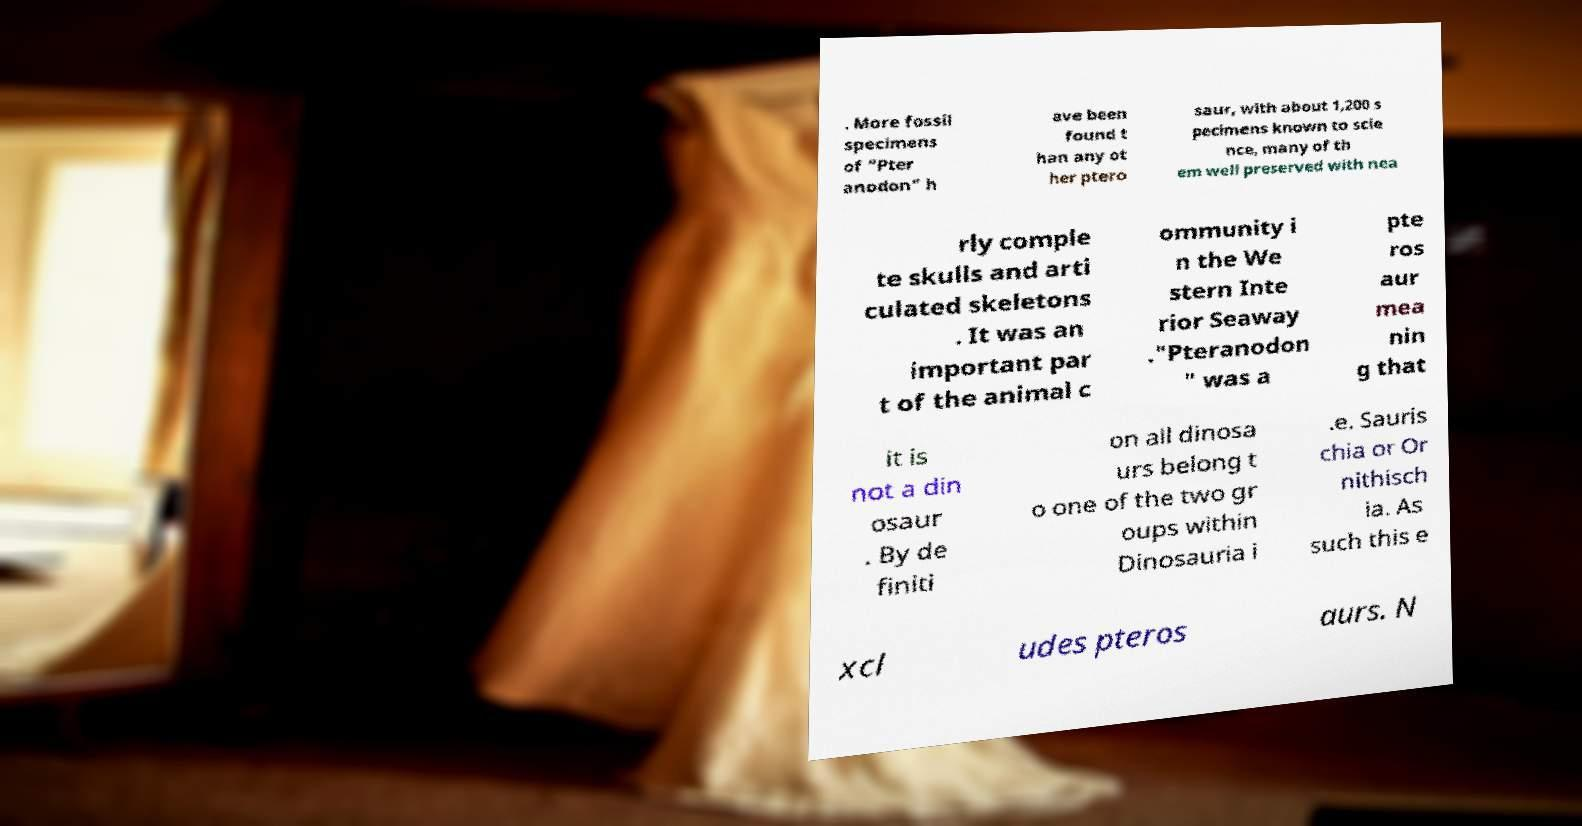Please identify and transcribe the text found in this image. . More fossil specimens of "Pter anodon" h ave been found t han any ot her ptero saur, with about 1,200 s pecimens known to scie nce, many of th em well preserved with nea rly comple te skulls and arti culated skeletons . It was an important par t of the animal c ommunity i n the We stern Inte rior Seaway ."Pteranodon " was a pte ros aur mea nin g that it is not a din osaur . By de finiti on all dinosa urs belong t o one of the two gr oups within Dinosauria i .e. Sauris chia or Or nithisch ia. As such this e xcl udes pteros aurs. N 